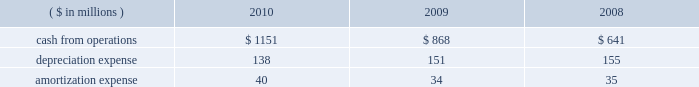During 2010 , we granted 3.8 million rsus and 1.1 million employee sars .
See footnote no .
4 , 201cshare-based compensation , 201d of the notes to our financial statements for additional information .
New accounting standards see footnote no .
1 , 201csummary of significant accounting policies , 201d of the notes to our financial statements for information related to our adoption of new accounting standards in 2010 and for information on our anticipated adoption of recently issued accounting standards .
Liquidity and capital resources cash requirements and our credit facilities our credit facility , which expires on may 14 , 2012 , and associated letters of credit , provide for $ 2.4 billion of aggregate effective borrowings .
Borrowings under the credit facility bear interest at the london interbank offered rate ( libor ) plus a fixed spread based on the credit ratings for our public debt .
We also pay quarterly fees on the credit facility at a rate based on our public debt rating .
For additional information on our credit facility , including participating financial institutions , see exhibit 10 , 201camended and restated credit agreement , 201d to our current report on form 8-k filed with the sec on may 16 , 2007 .
Although our credit facility does not expire until 2012 , we expect that we may extend or replace it during 2011 .
The credit facility contains certain covenants , including a single financial covenant that limits our maximum leverage ( consisting of adjusted total debt to consolidated ebitda , each as defined in the credit facility ) to not more than 4 to 1 .
Our outstanding public debt does not contain a corresponding financial covenant or a requirement that we maintain certain financial ratios .
We currently satisfy the covenants in our credit facility and public debt instruments , including the leverage covenant under the credit facility , and do not expect the covenants to restrict our ability to meet our anticipated borrowing and guarantee levels or increase those levels should we need to do so in the future .
We believe the credit facility , together with cash we expect to generate from operations and our ability to raise capital , remains adequate to meet our short-term and long-term liquidity requirements , finance our long-term growth plans , meet debt service , and fulfill other cash requirements .
At year-end 2010 , our available borrowing capacity amounted to $ 2.831 billion and reflected borrowing capacity of $ 2.326 billion under our credit facility and our cash balance of $ 505 million .
We calculate that borrowing capacity by taking $ 2.404 billion of effective aggregate bank commitments under our credit facility and subtracting $ 78 million of outstanding letters of credit under our credit facility .
During 2010 , we repaid our outstanding credit facility borrowings and had no outstanding balance at year-end .
As noted in the previous paragraphs , we anticipate that this available capacity will be adequate to fund our liquidity needs .
Since we continue to have ample flexibility under the credit facility 2019s covenants , we also expect that undrawn bank commitments under the credit facility will remain available to us even if business conditions were to deteriorate markedly .
Cash from operations cash from operations , depreciation expense , and amortization expense for the last three fiscal years are as follows : ( $ in millions ) 2010 2009 2008 .
Our ratio of current assets to current liabilities was roughly 1.4 to 1.0 at year-end 2010 and 1.2 to 1.0 at year-end 2009 .
We minimize working capital through cash management , strict credit-granting policies , and aggressive collection efforts .
We also have significant borrowing capacity under our credit facility should we need additional working capital. .
What was the percentage change in cash from operations between 2009 and 2010? 
Computations: ((1151 - 868) / 868)
Answer: 0.32604. 